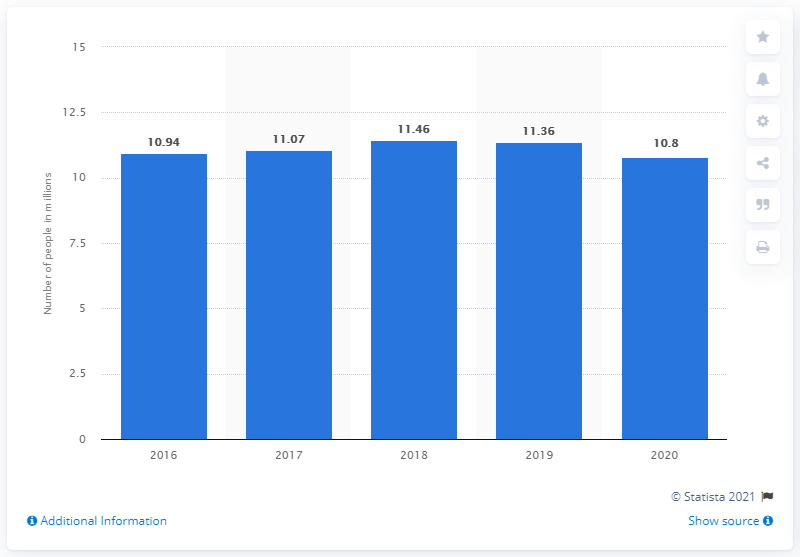Outline some significant characteristics in this image. In 2019, the number of German travelers who preferred camping vacations for leisure travel was 11.36 million. In 2020, 10.8% of Germans preferred camping vacations for leisure travel. 